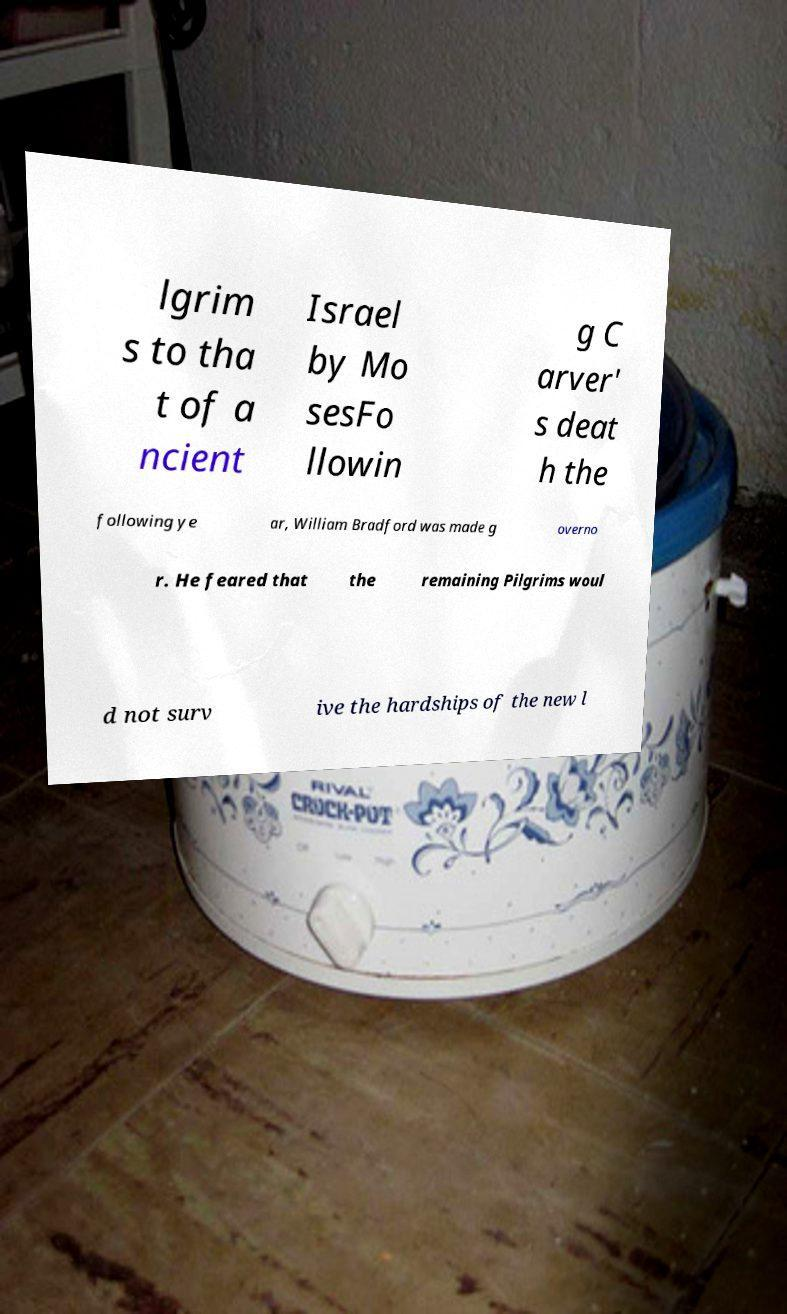Can you accurately transcribe the text from the provided image for me? lgrim s to tha t of a ncient Israel by Mo sesFo llowin g C arver' s deat h the following ye ar, William Bradford was made g overno r. He feared that the remaining Pilgrims woul d not surv ive the hardships of the new l 